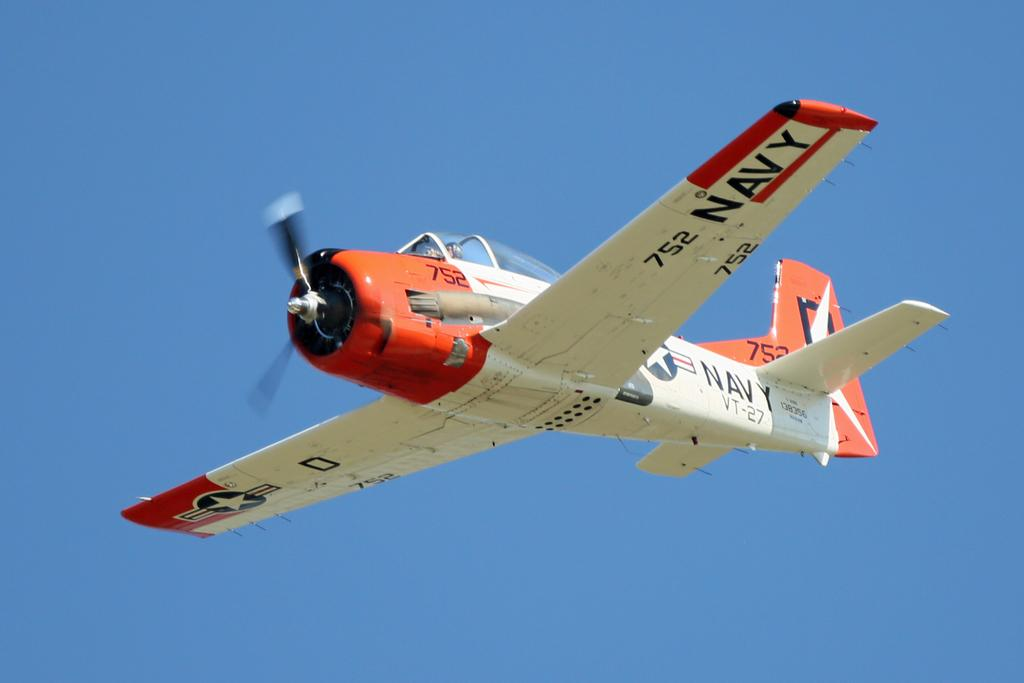<image>
Render a clear and concise summary of the photo. A red and white Navy airplane in a blue sky. 